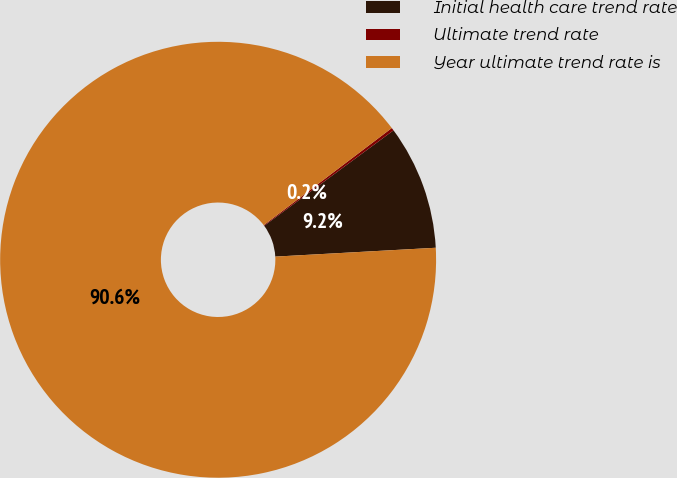Convert chart to OTSL. <chart><loc_0><loc_0><loc_500><loc_500><pie_chart><fcel>Initial health care trend rate<fcel>Ultimate trend rate<fcel>Year ultimate trend rate is<nl><fcel>9.24%<fcel>0.21%<fcel>90.55%<nl></chart> 